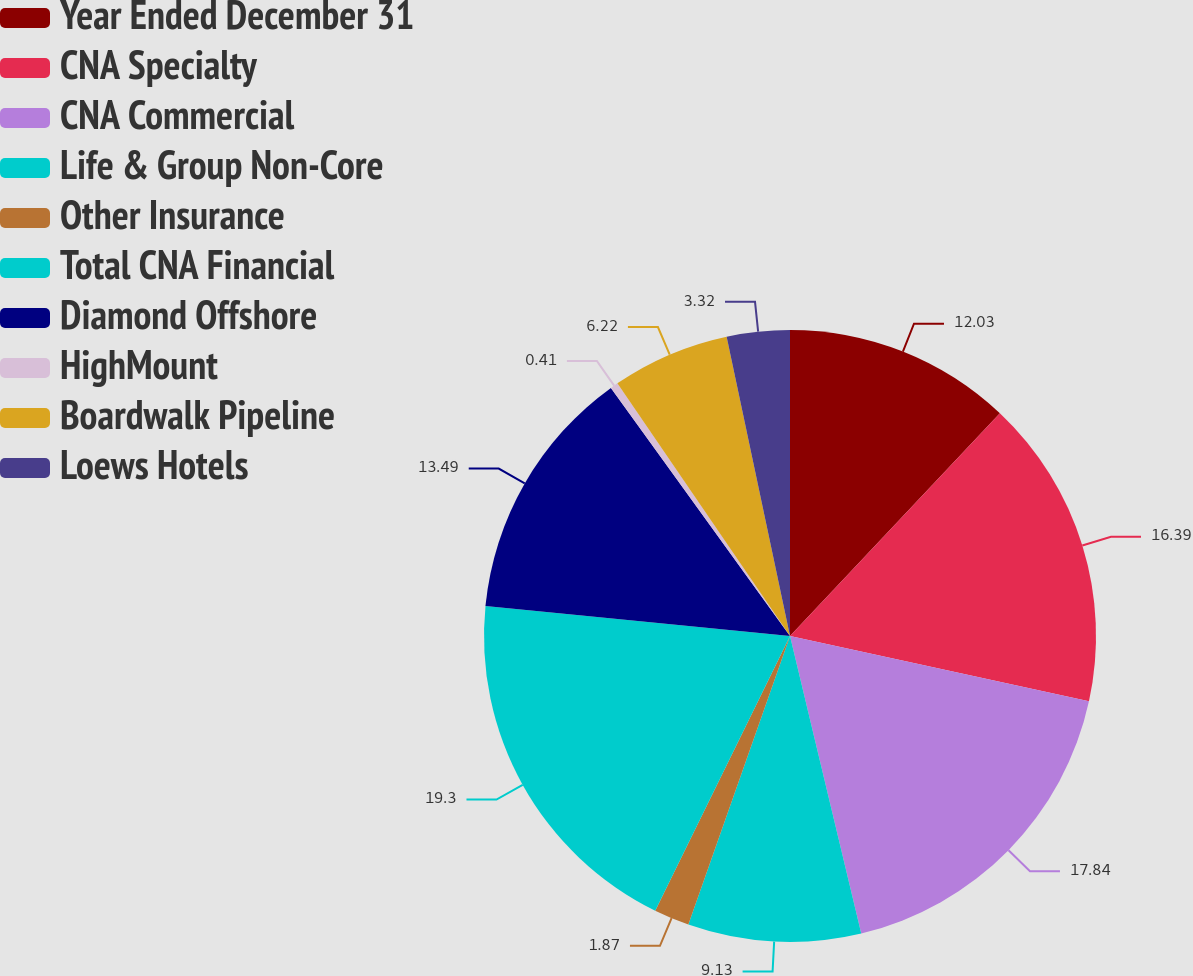Convert chart. <chart><loc_0><loc_0><loc_500><loc_500><pie_chart><fcel>Year Ended December 31<fcel>CNA Specialty<fcel>CNA Commercial<fcel>Life & Group Non-Core<fcel>Other Insurance<fcel>Total CNA Financial<fcel>Diamond Offshore<fcel>HighMount<fcel>Boardwalk Pipeline<fcel>Loews Hotels<nl><fcel>12.03%<fcel>16.39%<fcel>17.84%<fcel>9.13%<fcel>1.87%<fcel>19.3%<fcel>13.49%<fcel>0.41%<fcel>6.22%<fcel>3.32%<nl></chart> 